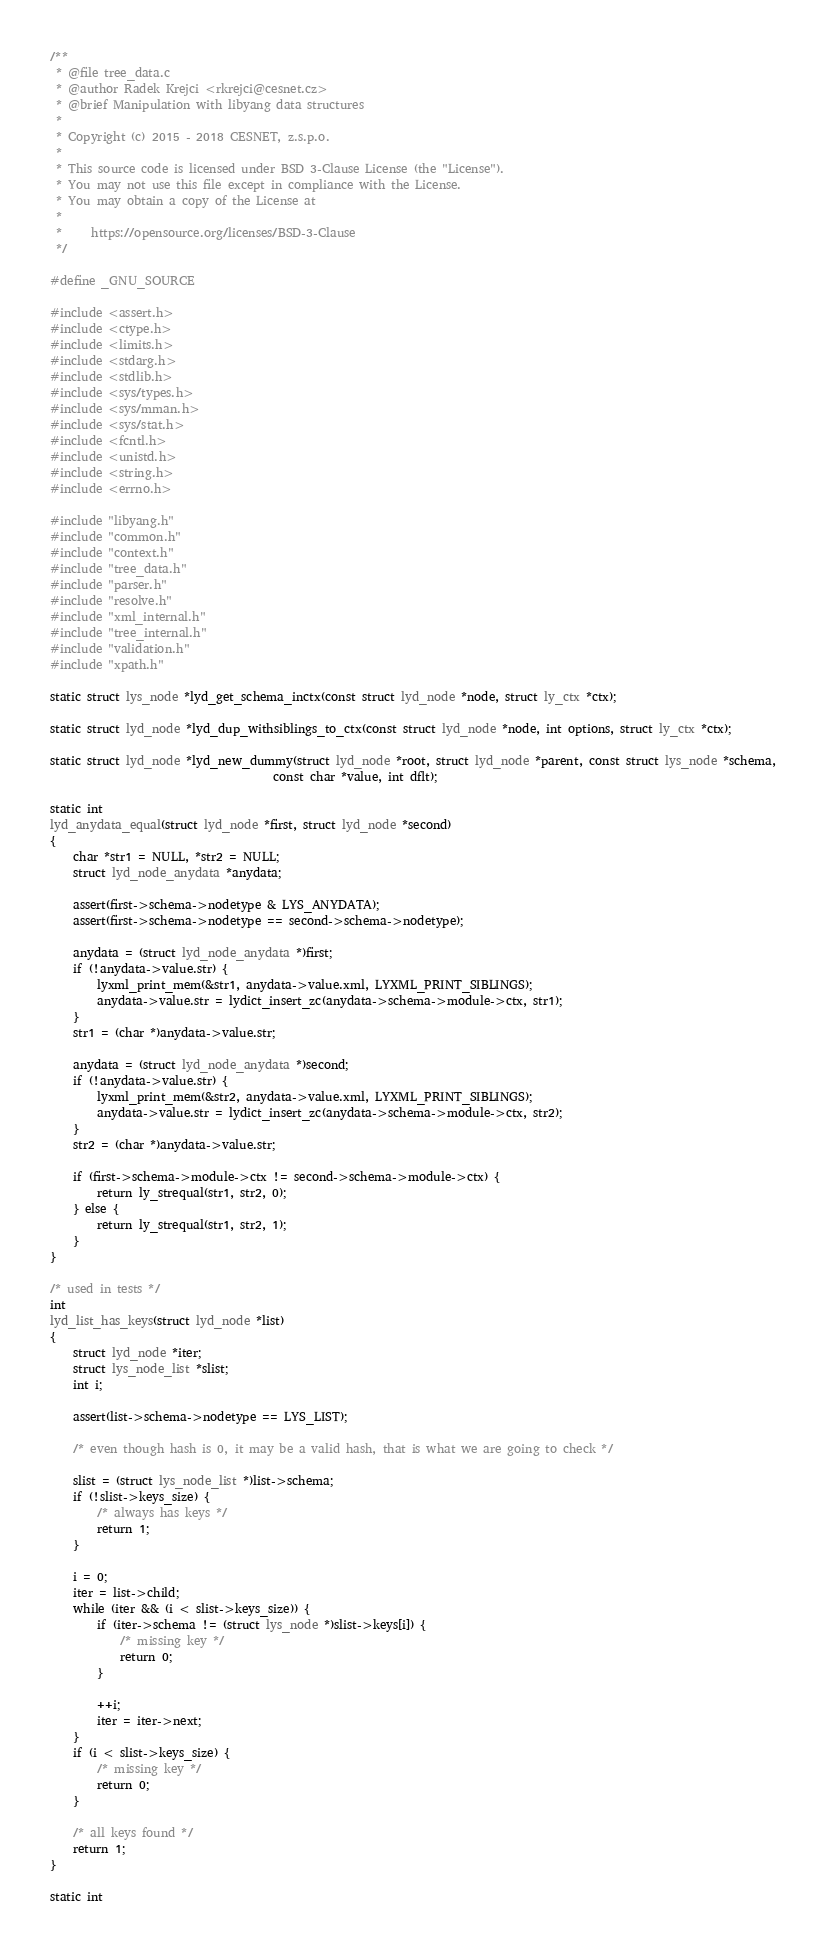<code> <loc_0><loc_0><loc_500><loc_500><_C_>/**
 * @file tree_data.c
 * @author Radek Krejci <rkrejci@cesnet.cz>
 * @brief Manipulation with libyang data structures
 *
 * Copyright (c) 2015 - 2018 CESNET, z.s.p.o.
 *
 * This source code is licensed under BSD 3-Clause License (the "License").
 * You may not use this file except in compliance with the License.
 * You may obtain a copy of the License at
 *
 *     https://opensource.org/licenses/BSD-3-Clause
 */

#define _GNU_SOURCE

#include <assert.h>
#include <ctype.h>
#include <limits.h>
#include <stdarg.h>
#include <stdlib.h>
#include <sys/types.h>
#include <sys/mman.h>
#include <sys/stat.h>
#include <fcntl.h>
#include <unistd.h>
#include <string.h>
#include <errno.h>

#include "libyang.h"
#include "common.h"
#include "context.h"
#include "tree_data.h"
#include "parser.h"
#include "resolve.h"
#include "xml_internal.h"
#include "tree_internal.h"
#include "validation.h"
#include "xpath.h"

static struct lys_node *lyd_get_schema_inctx(const struct lyd_node *node, struct ly_ctx *ctx);

static struct lyd_node *lyd_dup_withsiblings_to_ctx(const struct lyd_node *node, int options, struct ly_ctx *ctx);

static struct lyd_node *lyd_new_dummy(struct lyd_node *root, struct lyd_node *parent, const struct lys_node *schema,
                                      const char *value, int dflt);

static int
lyd_anydata_equal(struct lyd_node *first, struct lyd_node *second)
{
    char *str1 = NULL, *str2 = NULL;
    struct lyd_node_anydata *anydata;

    assert(first->schema->nodetype & LYS_ANYDATA);
    assert(first->schema->nodetype == second->schema->nodetype);

    anydata = (struct lyd_node_anydata *)first;
    if (!anydata->value.str) {
        lyxml_print_mem(&str1, anydata->value.xml, LYXML_PRINT_SIBLINGS);
        anydata->value.str = lydict_insert_zc(anydata->schema->module->ctx, str1);
    }
    str1 = (char *)anydata->value.str;

    anydata = (struct lyd_node_anydata *)second;
    if (!anydata->value.str) {
        lyxml_print_mem(&str2, anydata->value.xml, LYXML_PRINT_SIBLINGS);
        anydata->value.str = lydict_insert_zc(anydata->schema->module->ctx, str2);
    }
    str2 = (char *)anydata->value.str;

    if (first->schema->module->ctx != second->schema->module->ctx) {
        return ly_strequal(str1, str2, 0);
    } else {
        return ly_strequal(str1, str2, 1);
    }
}

/* used in tests */
int
lyd_list_has_keys(struct lyd_node *list)
{
    struct lyd_node *iter;
    struct lys_node_list *slist;
    int i;

    assert(list->schema->nodetype == LYS_LIST);

    /* even though hash is 0, it may be a valid hash, that is what we are going to check */

    slist = (struct lys_node_list *)list->schema;
    if (!slist->keys_size) {
        /* always has keys */
        return 1;
    }

    i = 0;
    iter = list->child;
    while (iter && (i < slist->keys_size)) {
        if (iter->schema != (struct lys_node *)slist->keys[i]) {
            /* missing key */
            return 0;
        }

        ++i;
        iter = iter->next;
    }
    if (i < slist->keys_size) {
        /* missing key */
        return 0;
    }

    /* all keys found */
    return 1;
}

static int</code> 